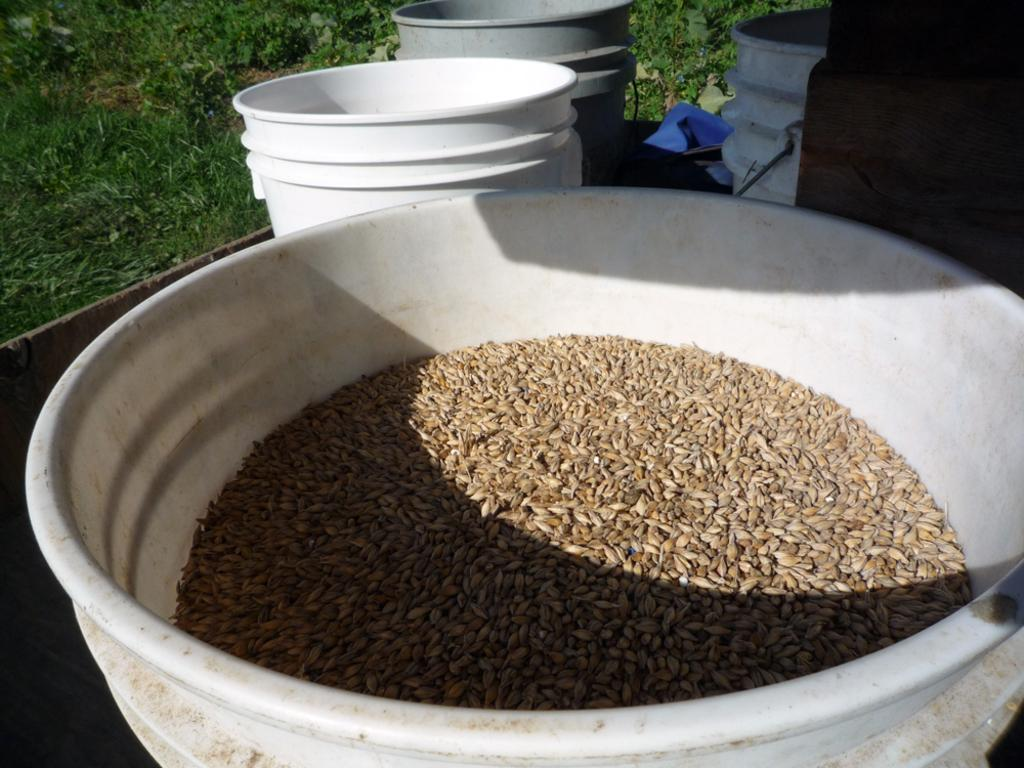What is stored in the container in the image? There are food grains in a container in the image. What type of objects are visible near the container? There are buckets visible in the image. What material is present in the image? There is wood present in the image. What type of vegetation can be seen in the image? There is grass visible in the image. What is the color of the blue object in the image? There is a blue colored object in the image. Can you hear the owl hooting in the image? There is no owl present in the image, so it cannot be heard hooting. 